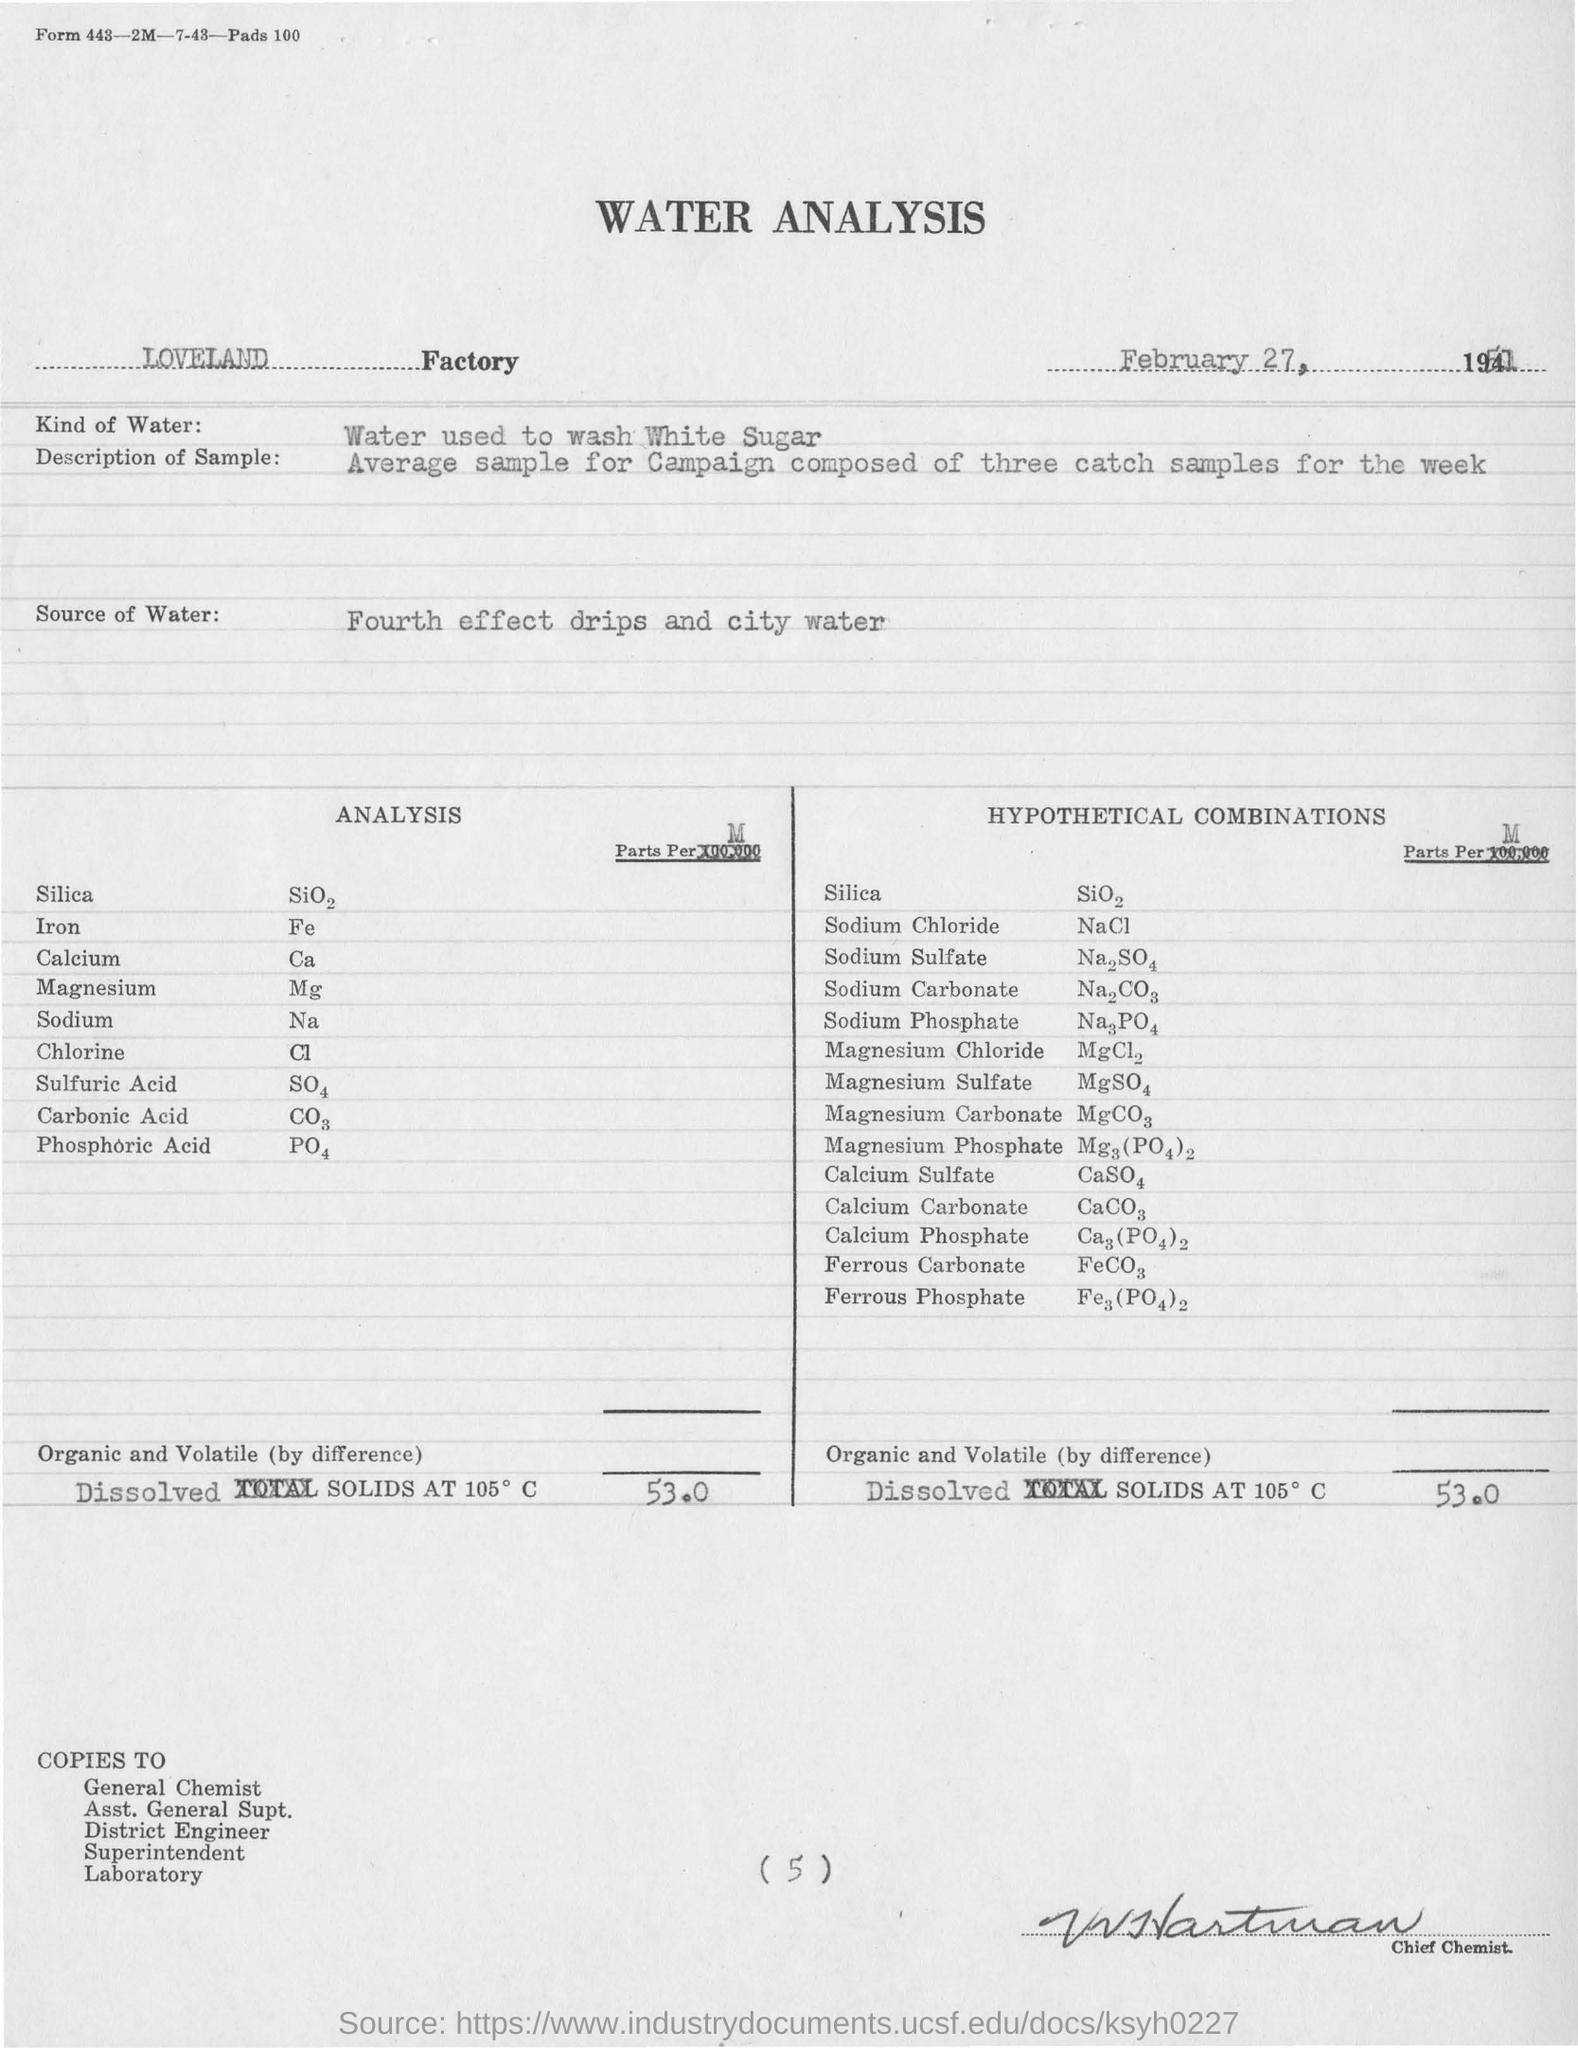Which factory is mentioned in the document?
Offer a terse response. Loveland. Wha is the Source of Water?
Ensure brevity in your answer.  Fourth effect drips and city water. 